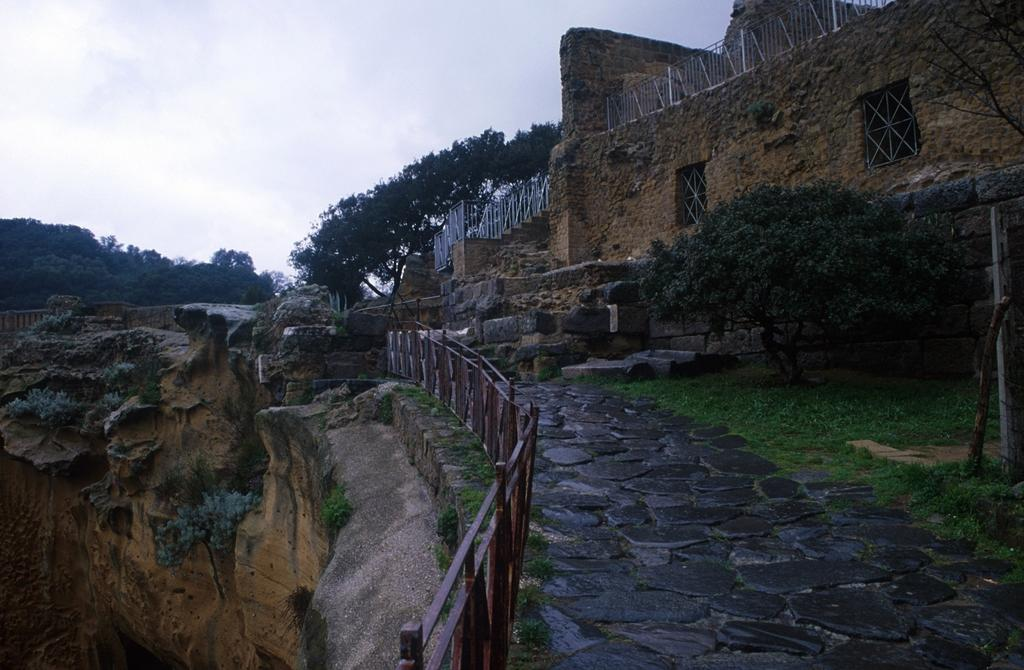What type of structure is in the image? There is a fort in the image. What features can be seen on the fort? The fort has windows, grills, and a wall. What type of vegetation is present in the image? There are trees and grass in the image. What can be seen in the background of the image? The sky is visible in the background of the image. Can you see any popcorn floating in the lake in the image? There is no lake or popcorn present in the image. What type of lumber is being used to construct the fort in the image? The image does not provide information about the type of lumber used to construct the fort. 